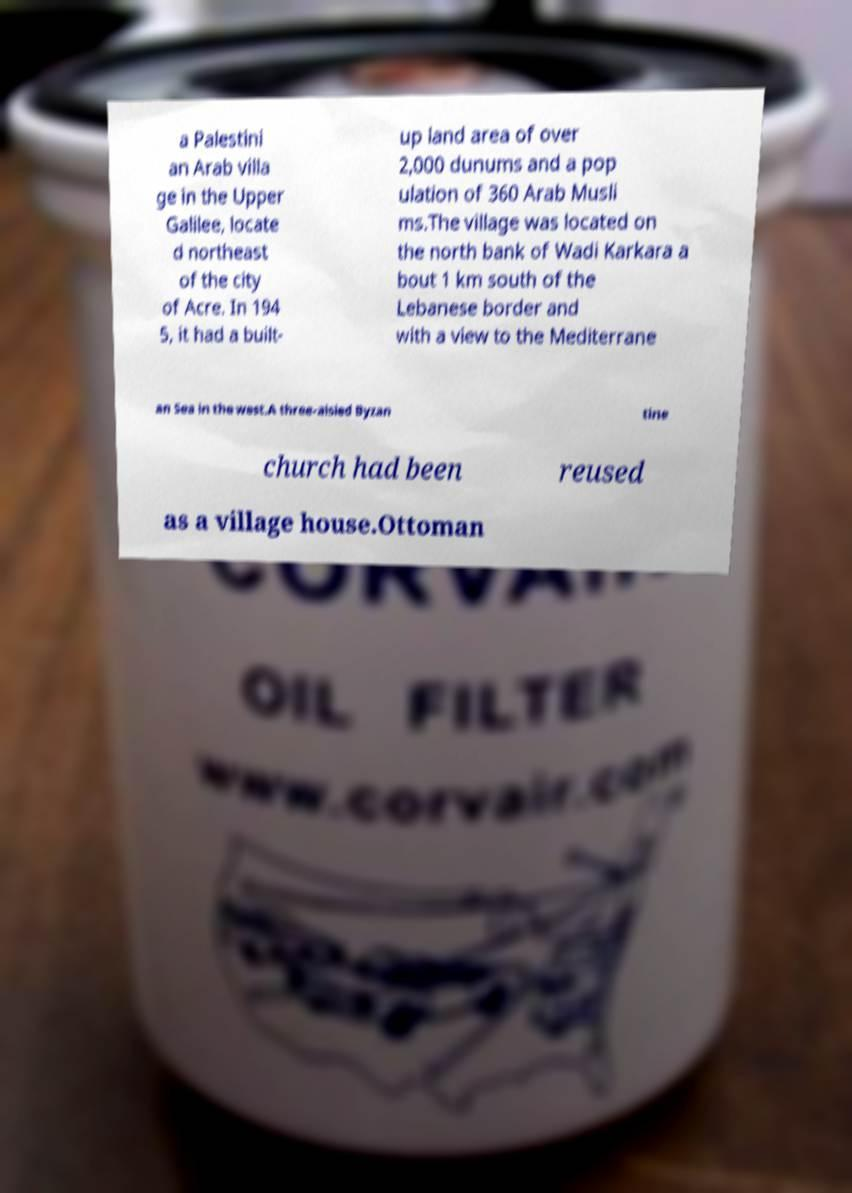I need the written content from this picture converted into text. Can you do that? a Palestini an Arab villa ge in the Upper Galilee, locate d northeast of the city of Acre. In 194 5, it had a built- up land area of over 2,000 dunums and a pop ulation of 360 Arab Musli ms.The village was located on the north bank of Wadi Karkara a bout 1 km south of the Lebanese border and with a view to the Mediterrane an Sea in the west.A three-aisled Byzan tine church had been reused as a village house.Ottoman 